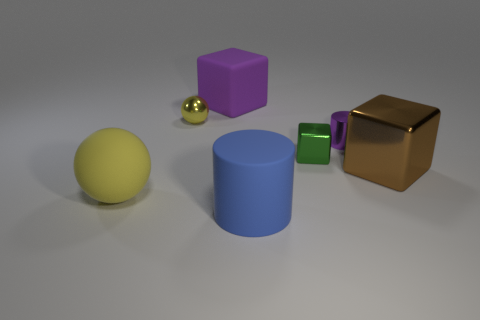Add 2 tiny gray objects. How many objects exist? 9 Subtract all cubes. How many objects are left? 4 Subtract all large blue metallic cylinders. Subtract all small green metallic cubes. How many objects are left? 6 Add 3 large cylinders. How many large cylinders are left? 4 Add 5 big blue objects. How many big blue objects exist? 6 Subtract 0 gray cubes. How many objects are left? 7 